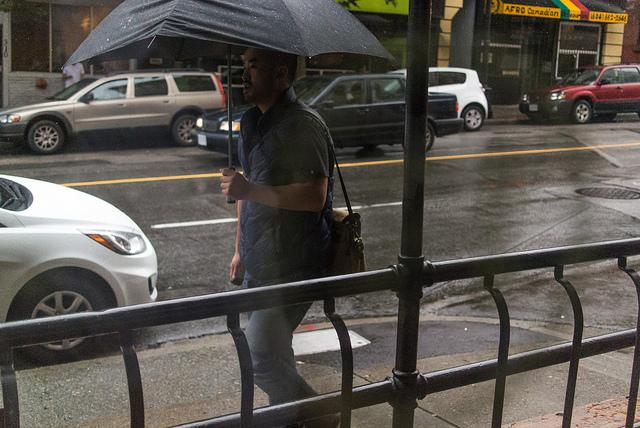From what does the man with the umbrella protect himself?

Choices:
A) rain
B) snow
C) sun glare
D) gunfire rain 